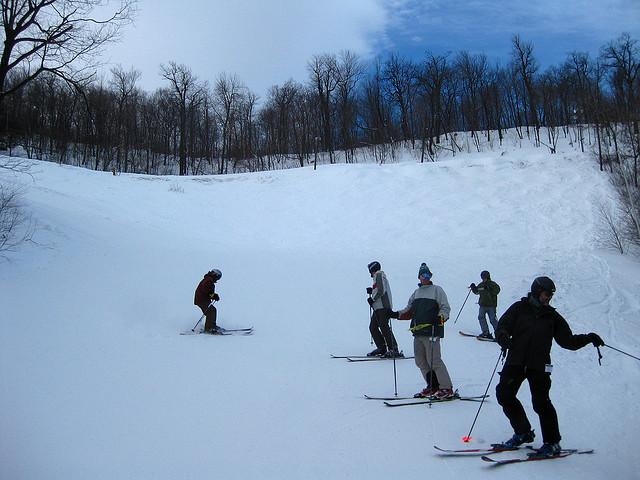Are their leaves on the trees?
Short answer required. No. Where are the people skiing?
Quick response, please. Hill. How many people?
Quick response, please. 5. Are they skiing?
Quick response, please. Yes. 